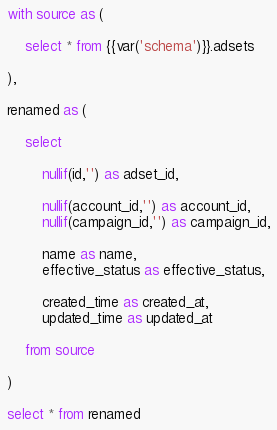<code> <loc_0><loc_0><loc_500><loc_500><_SQL_>with source as (

    select * from {{var('schema')}}.adsets

),

renamed as (

    select

        nullif(id,'') as adset_id,

        nullif(account_id,'') as account_id,
        nullif(campaign_id,'') as campaign_id,

        name as name,
        effective_status as effective_status,

        created_time as created_at,
        updated_time as updated_at

    from source

)

select * from renamed

</code> 